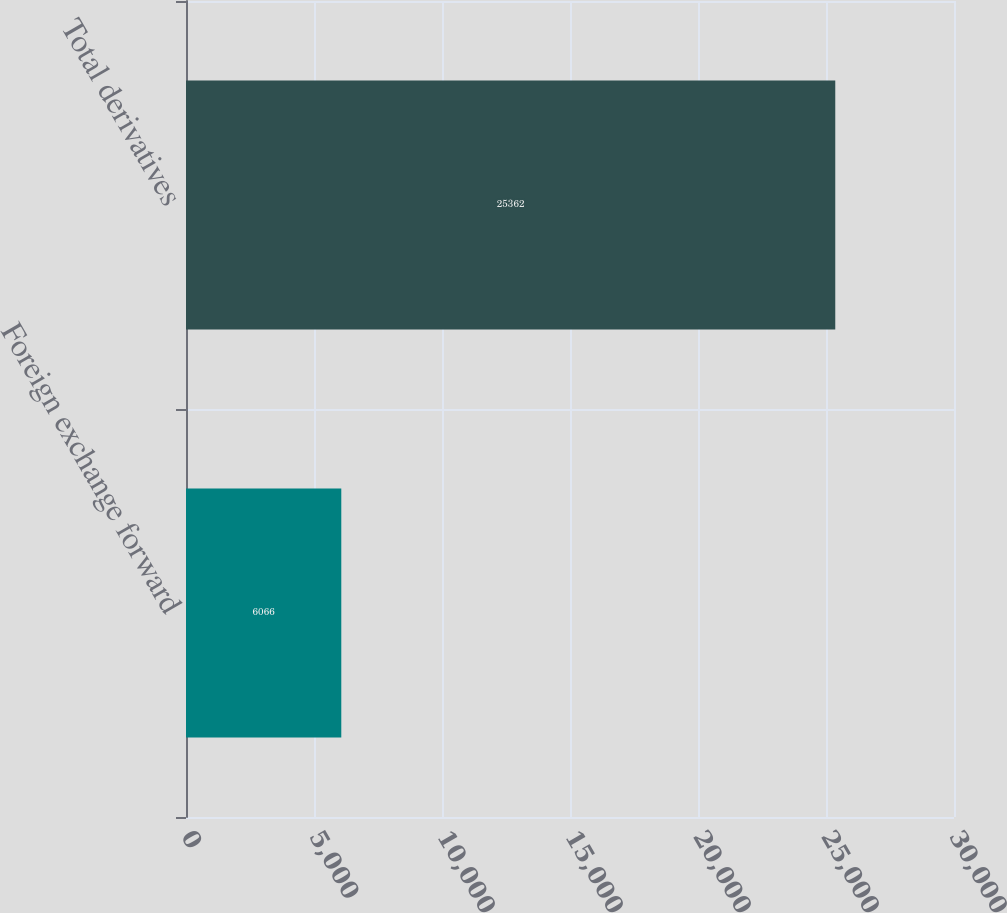<chart> <loc_0><loc_0><loc_500><loc_500><bar_chart><fcel>Foreign exchange forward<fcel>Total derivatives<nl><fcel>6066<fcel>25362<nl></chart> 